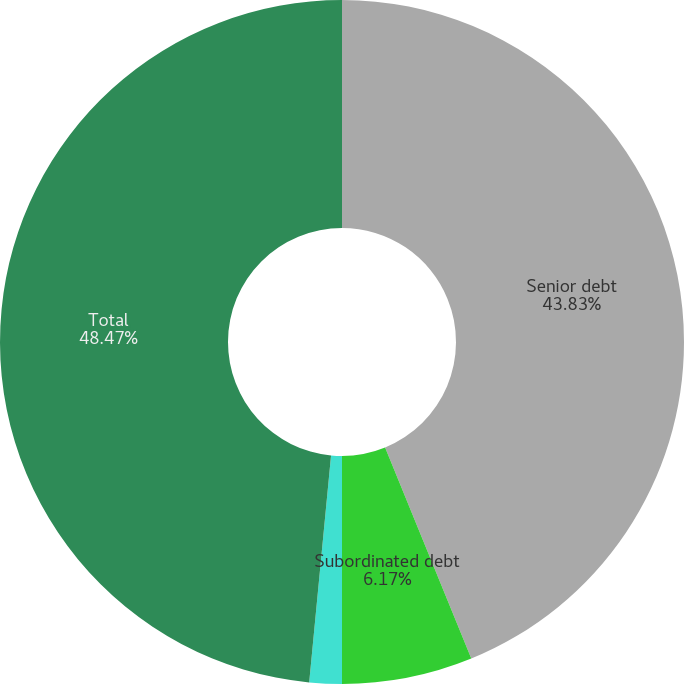<chart> <loc_0><loc_0><loc_500><loc_500><pie_chart><fcel>Senior debt<fcel>Subordinated debt<fcel>Junior subordinated debentures<fcel>Total<nl><fcel>43.83%<fcel>6.17%<fcel>1.53%<fcel>48.47%<nl></chart> 